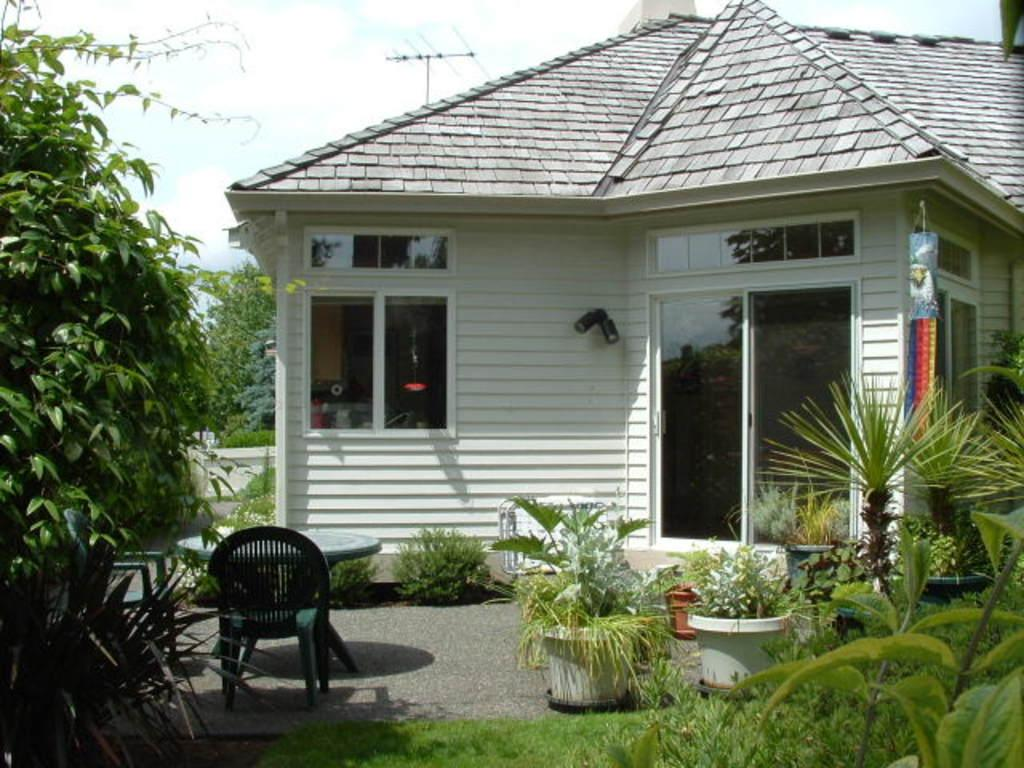What type of structure is visible in the image? There is a building in the image. What type of furniture is present in the image? There is a chair and a table in the image. What type of vegetation is visible in the image? There are plants in the image. What date is marked on the calendar in the image? There is no calendar present in the image. What type of behavior is exhibited by the plants in the image? The plants in the image are not exhibiting any behavior, as they are stationary vegetation. 